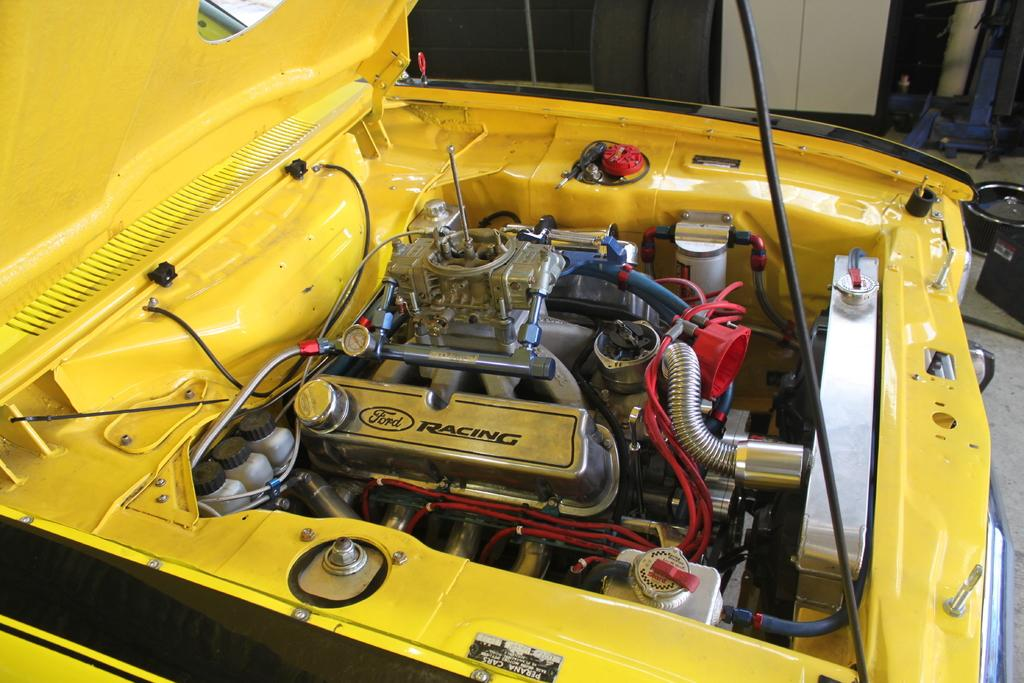What color is the car bonnet in the image? The car bonnet in the image is yellow. What can be seen on the floor in the background of the image? There are objects visible on the floor in the background of the image. What type of statement can be seen being made by the clam in the image? There is no clam present in the image, so it is not possible to answer that question. 